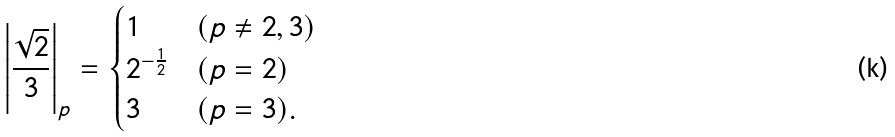Convert formula to latex. <formula><loc_0><loc_0><loc_500><loc_500>\left | \frac { \sqrt { 2 } } { 3 } \right | _ { p } = \begin{cases} 1 & ( p \neq 2 , 3 ) \\ 2 ^ { - \frac { 1 } { 2 } } & ( p = 2 ) \\ 3 & ( p = 3 ) . \end{cases}</formula> 